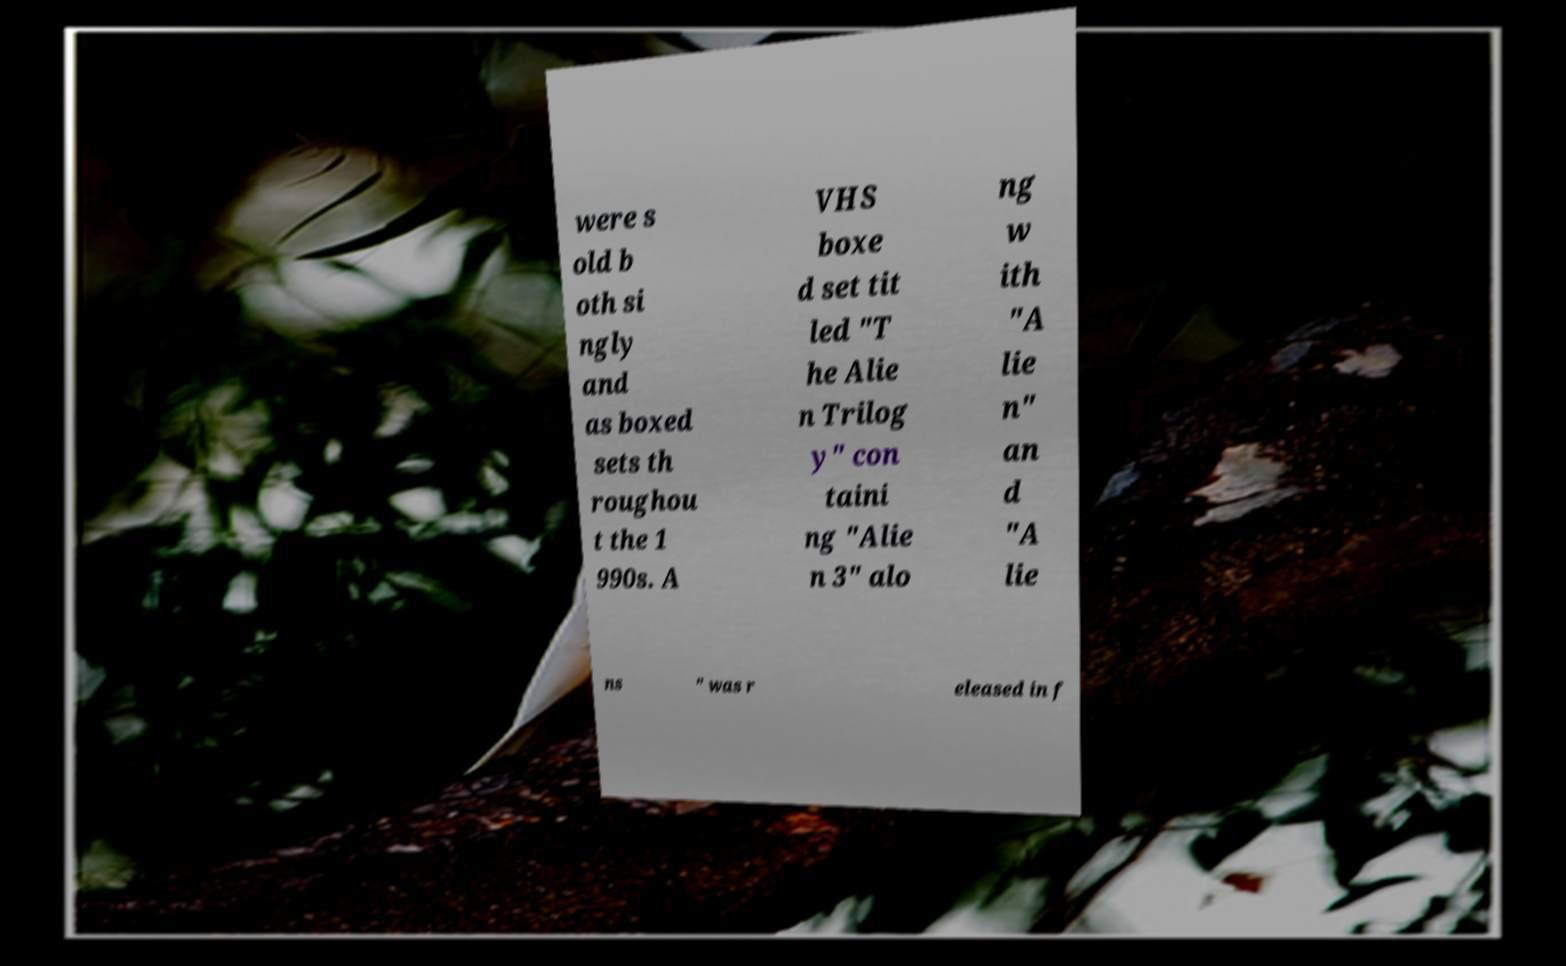I need the written content from this picture converted into text. Can you do that? were s old b oth si ngly and as boxed sets th roughou t the 1 990s. A VHS boxe d set tit led "T he Alie n Trilog y" con taini ng "Alie n 3" alo ng w ith "A lie n" an d "A lie ns " was r eleased in f 